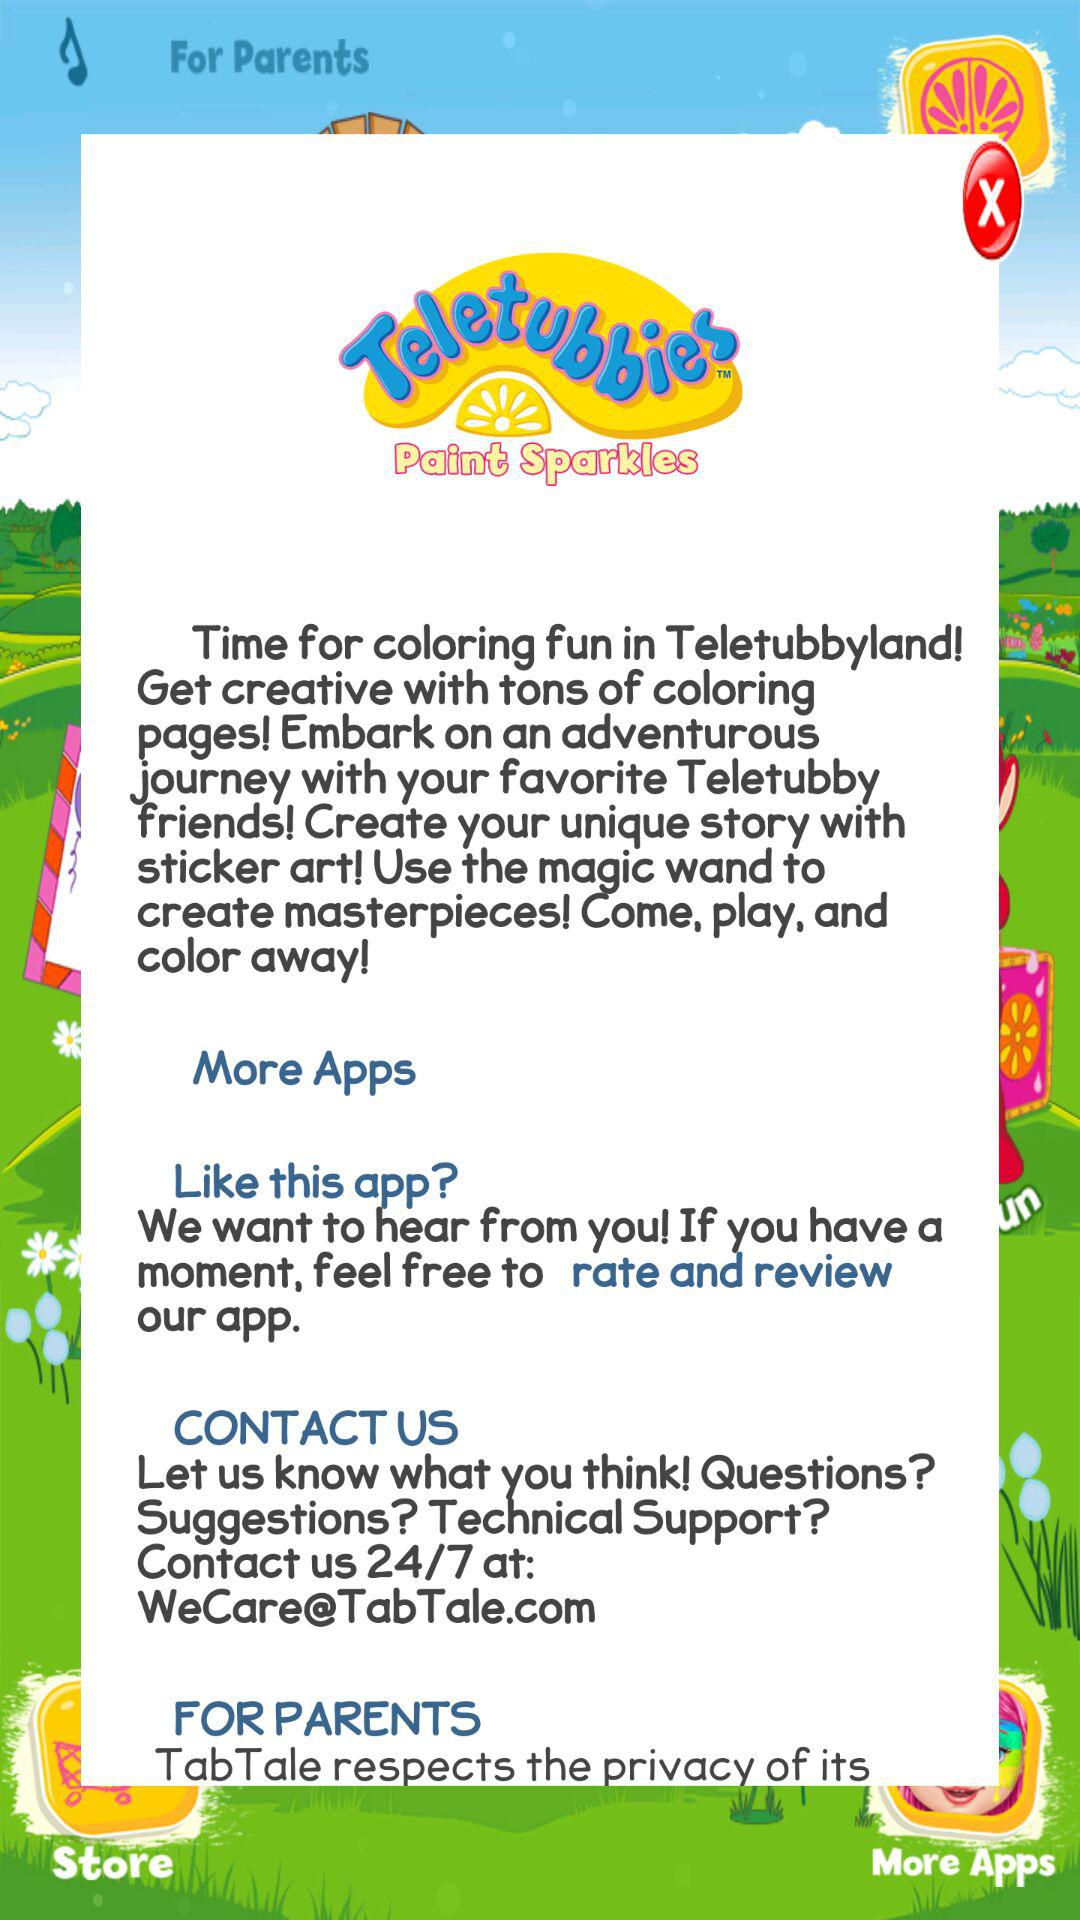What is the e-mail address for technical support? The email address for technical support is WeCare@TabTale.com. 